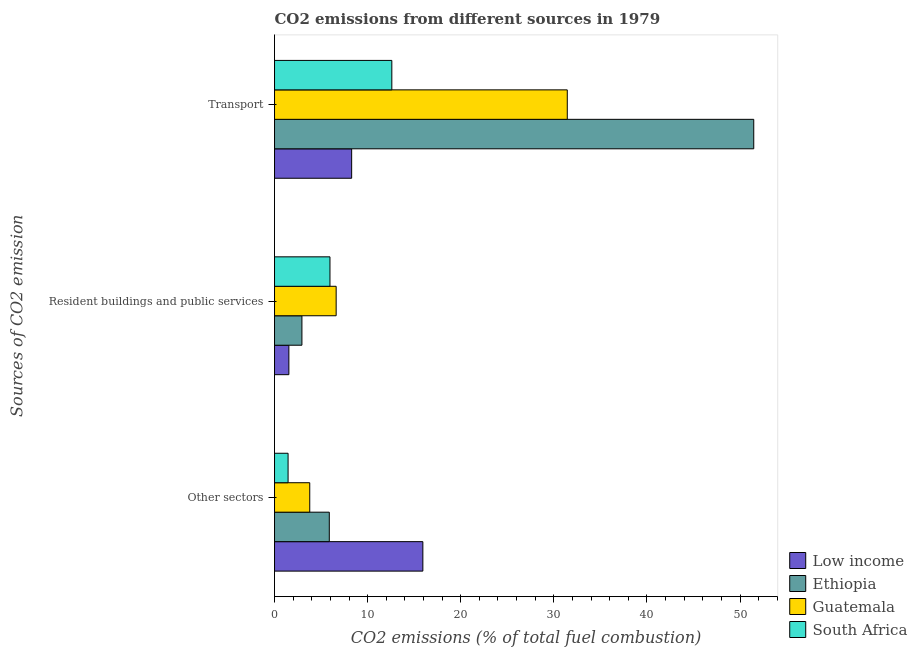How many different coloured bars are there?
Keep it short and to the point. 4. Are the number of bars per tick equal to the number of legend labels?
Ensure brevity in your answer.  Yes. How many bars are there on the 2nd tick from the bottom?
Your response must be concise. 4. What is the label of the 1st group of bars from the top?
Your response must be concise. Transport. What is the percentage of co2 emissions from other sectors in South Africa?
Give a very brief answer. 1.46. Across all countries, what is the maximum percentage of co2 emissions from resident buildings and public services?
Make the answer very short. 6.62. Across all countries, what is the minimum percentage of co2 emissions from resident buildings and public services?
Provide a short and direct response. 1.54. In which country was the percentage of co2 emissions from other sectors maximum?
Your response must be concise. Low income. In which country was the percentage of co2 emissions from resident buildings and public services minimum?
Provide a short and direct response. Low income. What is the total percentage of co2 emissions from other sectors in the graph?
Offer a very short reply. 27.05. What is the difference between the percentage of co2 emissions from transport in South Africa and that in Low income?
Provide a short and direct response. 4.31. What is the difference between the percentage of co2 emissions from resident buildings and public services in Low income and the percentage of co2 emissions from transport in South Africa?
Your answer should be compact. -11.06. What is the average percentage of co2 emissions from transport per country?
Make the answer very short. 25.95. What is the difference between the percentage of co2 emissions from transport and percentage of co2 emissions from resident buildings and public services in Ethiopia?
Offer a terse response. 48.53. What is the ratio of the percentage of co2 emissions from other sectors in Guatemala to that in Ethiopia?
Provide a short and direct response. 0.64. Is the percentage of co2 emissions from transport in Guatemala less than that in South Africa?
Offer a very short reply. No. What is the difference between the highest and the second highest percentage of co2 emissions from resident buildings and public services?
Keep it short and to the point. 0.67. What is the difference between the highest and the lowest percentage of co2 emissions from resident buildings and public services?
Your answer should be compact. 5.08. In how many countries, is the percentage of co2 emissions from other sectors greater than the average percentage of co2 emissions from other sectors taken over all countries?
Ensure brevity in your answer.  1. Is the sum of the percentage of co2 emissions from resident buildings and public services in Guatemala and Low income greater than the maximum percentage of co2 emissions from other sectors across all countries?
Give a very brief answer. No. What does the 3rd bar from the top in Other sectors represents?
Ensure brevity in your answer.  Ethiopia. What does the 2nd bar from the bottom in Transport represents?
Provide a short and direct response. Ethiopia. How many bars are there?
Your answer should be compact. 12. Are all the bars in the graph horizontal?
Your response must be concise. Yes. How many countries are there in the graph?
Provide a succinct answer. 4. What is the difference between two consecutive major ticks on the X-axis?
Ensure brevity in your answer.  10. Does the graph contain any zero values?
Keep it short and to the point. No. Where does the legend appear in the graph?
Your response must be concise. Bottom right. How many legend labels are there?
Provide a succinct answer. 4. How are the legend labels stacked?
Provide a succinct answer. Vertical. What is the title of the graph?
Provide a succinct answer. CO2 emissions from different sources in 1979. What is the label or title of the X-axis?
Your answer should be very brief. CO2 emissions (% of total fuel combustion). What is the label or title of the Y-axis?
Ensure brevity in your answer.  Sources of CO2 emission. What is the CO2 emissions (% of total fuel combustion) of Low income in Other sectors?
Provide a short and direct response. 15.93. What is the CO2 emissions (% of total fuel combustion) of Ethiopia in Other sectors?
Offer a terse response. 5.88. What is the CO2 emissions (% of total fuel combustion) in Guatemala in Other sectors?
Make the answer very short. 3.78. What is the CO2 emissions (% of total fuel combustion) of South Africa in Other sectors?
Your answer should be compact. 1.46. What is the CO2 emissions (% of total fuel combustion) of Low income in Resident buildings and public services?
Make the answer very short. 1.54. What is the CO2 emissions (% of total fuel combustion) of Ethiopia in Resident buildings and public services?
Keep it short and to the point. 2.94. What is the CO2 emissions (% of total fuel combustion) in Guatemala in Resident buildings and public services?
Your answer should be very brief. 6.62. What is the CO2 emissions (% of total fuel combustion) of South Africa in Resident buildings and public services?
Your response must be concise. 5.95. What is the CO2 emissions (% of total fuel combustion) in Low income in Transport?
Offer a terse response. 8.28. What is the CO2 emissions (% of total fuel combustion) in Ethiopia in Transport?
Ensure brevity in your answer.  51.47. What is the CO2 emissions (% of total fuel combustion) of Guatemala in Transport?
Provide a succinct answer. 31.44. What is the CO2 emissions (% of total fuel combustion) of South Africa in Transport?
Give a very brief answer. 12.6. Across all Sources of CO2 emission, what is the maximum CO2 emissions (% of total fuel combustion) of Low income?
Give a very brief answer. 15.93. Across all Sources of CO2 emission, what is the maximum CO2 emissions (% of total fuel combustion) of Ethiopia?
Your response must be concise. 51.47. Across all Sources of CO2 emission, what is the maximum CO2 emissions (% of total fuel combustion) in Guatemala?
Provide a succinct answer. 31.44. Across all Sources of CO2 emission, what is the maximum CO2 emissions (% of total fuel combustion) in South Africa?
Keep it short and to the point. 12.6. Across all Sources of CO2 emission, what is the minimum CO2 emissions (% of total fuel combustion) of Low income?
Keep it short and to the point. 1.54. Across all Sources of CO2 emission, what is the minimum CO2 emissions (% of total fuel combustion) of Ethiopia?
Your answer should be compact. 2.94. Across all Sources of CO2 emission, what is the minimum CO2 emissions (% of total fuel combustion) in Guatemala?
Your answer should be compact. 3.78. Across all Sources of CO2 emission, what is the minimum CO2 emissions (% of total fuel combustion) of South Africa?
Provide a short and direct response. 1.46. What is the total CO2 emissions (% of total fuel combustion) of Low income in the graph?
Give a very brief answer. 25.76. What is the total CO2 emissions (% of total fuel combustion) in Ethiopia in the graph?
Ensure brevity in your answer.  60.29. What is the total CO2 emissions (% of total fuel combustion) of Guatemala in the graph?
Your answer should be compact. 41.84. What is the total CO2 emissions (% of total fuel combustion) of South Africa in the graph?
Your answer should be compact. 20.01. What is the difference between the CO2 emissions (% of total fuel combustion) in Low income in Other sectors and that in Resident buildings and public services?
Your answer should be very brief. 14.39. What is the difference between the CO2 emissions (% of total fuel combustion) of Ethiopia in Other sectors and that in Resident buildings and public services?
Your answer should be compact. 2.94. What is the difference between the CO2 emissions (% of total fuel combustion) in Guatemala in Other sectors and that in Resident buildings and public services?
Provide a short and direct response. -2.84. What is the difference between the CO2 emissions (% of total fuel combustion) in South Africa in Other sectors and that in Resident buildings and public services?
Offer a very short reply. -4.5. What is the difference between the CO2 emissions (% of total fuel combustion) in Low income in Other sectors and that in Transport?
Provide a succinct answer. 7.65. What is the difference between the CO2 emissions (% of total fuel combustion) of Ethiopia in Other sectors and that in Transport?
Your answer should be very brief. -45.59. What is the difference between the CO2 emissions (% of total fuel combustion) in Guatemala in Other sectors and that in Transport?
Keep it short and to the point. -27.66. What is the difference between the CO2 emissions (% of total fuel combustion) of South Africa in Other sectors and that in Transport?
Make the answer very short. -11.14. What is the difference between the CO2 emissions (% of total fuel combustion) in Low income in Resident buildings and public services and that in Transport?
Your answer should be compact. -6.74. What is the difference between the CO2 emissions (% of total fuel combustion) in Ethiopia in Resident buildings and public services and that in Transport?
Keep it short and to the point. -48.53. What is the difference between the CO2 emissions (% of total fuel combustion) in Guatemala in Resident buildings and public services and that in Transport?
Your response must be concise. -24.82. What is the difference between the CO2 emissions (% of total fuel combustion) in South Africa in Resident buildings and public services and that in Transport?
Provide a succinct answer. -6.64. What is the difference between the CO2 emissions (% of total fuel combustion) of Low income in Other sectors and the CO2 emissions (% of total fuel combustion) of Ethiopia in Resident buildings and public services?
Your answer should be compact. 12.99. What is the difference between the CO2 emissions (% of total fuel combustion) in Low income in Other sectors and the CO2 emissions (% of total fuel combustion) in Guatemala in Resident buildings and public services?
Your answer should be compact. 9.31. What is the difference between the CO2 emissions (% of total fuel combustion) of Low income in Other sectors and the CO2 emissions (% of total fuel combustion) of South Africa in Resident buildings and public services?
Ensure brevity in your answer.  9.98. What is the difference between the CO2 emissions (% of total fuel combustion) of Ethiopia in Other sectors and the CO2 emissions (% of total fuel combustion) of Guatemala in Resident buildings and public services?
Your answer should be compact. -0.74. What is the difference between the CO2 emissions (% of total fuel combustion) of Ethiopia in Other sectors and the CO2 emissions (% of total fuel combustion) of South Africa in Resident buildings and public services?
Provide a succinct answer. -0.07. What is the difference between the CO2 emissions (% of total fuel combustion) of Guatemala in Other sectors and the CO2 emissions (% of total fuel combustion) of South Africa in Resident buildings and public services?
Offer a terse response. -2.17. What is the difference between the CO2 emissions (% of total fuel combustion) in Low income in Other sectors and the CO2 emissions (% of total fuel combustion) in Ethiopia in Transport?
Offer a very short reply. -35.54. What is the difference between the CO2 emissions (% of total fuel combustion) of Low income in Other sectors and the CO2 emissions (% of total fuel combustion) of Guatemala in Transport?
Give a very brief answer. -15.51. What is the difference between the CO2 emissions (% of total fuel combustion) of Low income in Other sectors and the CO2 emissions (% of total fuel combustion) of South Africa in Transport?
Provide a short and direct response. 3.33. What is the difference between the CO2 emissions (% of total fuel combustion) of Ethiopia in Other sectors and the CO2 emissions (% of total fuel combustion) of Guatemala in Transport?
Offer a very short reply. -25.56. What is the difference between the CO2 emissions (% of total fuel combustion) of Ethiopia in Other sectors and the CO2 emissions (% of total fuel combustion) of South Africa in Transport?
Offer a terse response. -6.72. What is the difference between the CO2 emissions (% of total fuel combustion) in Guatemala in Other sectors and the CO2 emissions (% of total fuel combustion) in South Africa in Transport?
Give a very brief answer. -8.82. What is the difference between the CO2 emissions (% of total fuel combustion) of Low income in Resident buildings and public services and the CO2 emissions (% of total fuel combustion) of Ethiopia in Transport?
Your response must be concise. -49.93. What is the difference between the CO2 emissions (% of total fuel combustion) of Low income in Resident buildings and public services and the CO2 emissions (% of total fuel combustion) of Guatemala in Transport?
Your answer should be compact. -29.9. What is the difference between the CO2 emissions (% of total fuel combustion) of Low income in Resident buildings and public services and the CO2 emissions (% of total fuel combustion) of South Africa in Transport?
Offer a terse response. -11.06. What is the difference between the CO2 emissions (% of total fuel combustion) of Ethiopia in Resident buildings and public services and the CO2 emissions (% of total fuel combustion) of Guatemala in Transport?
Offer a terse response. -28.5. What is the difference between the CO2 emissions (% of total fuel combustion) of Ethiopia in Resident buildings and public services and the CO2 emissions (% of total fuel combustion) of South Africa in Transport?
Give a very brief answer. -9.66. What is the difference between the CO2 emissions (% of total fuel combustion) in Guatemala in Resident buildings and public services and the CO2 emissions (% of total fuel combustion) in South Africa in Transport?
Keep it short and to the point. -5.98. What is the average CO2 emissions (% of total fuel combustion) of Low income per Sources of CO2 emission?
Your answer should be very brief. 8.59. What is the average CO2 emissions (% of total fuel combustion) in Ethiopia per Sources of CO2 emission?
Your answer should be compact. 20.1. What is the average CO2 emissions (% of total fuel combustion) of Guatemala per Sources of CO2 emission?
Your response must be concise. 13.95. What is the average CO2 emissions (% of total fuel combustion) of South Africa per Sources of CO2 emission?
Make the answer very short. 6.67. What is the difference between the CO2 emissions (% of total fuel combustion) in Low income and CO2 emissions (% of total fuel combustion) in Ethiopia in Other sectors?
Give a very brief answer. 10.05. What is the difference between the CO2 emissions (% of total fuel combustion) of Low income and CO2 emissions (% of total fuel combustion) of Guatemala in Other sectors?
Your answer should be compact. 12.15. What is the difference between the CO2 emissions (% of total fuel combustion) in Low income and CO2 emissions (% of total fuel combustion) in South Africa in Other sectors?
Your response must be concise. 14.48. What is the difference between the CO2 emissions (% of total fuel combustion) in Ethiopia and CO2 emissions (% of total fuel combustion) in Guatemala in Other sectors?
Provide a succinct answer. 2.1. What is the difference between the CO2 emissions (% of total fuel combustion) of Ethiopia and CO2 emissions (% of total fuel combustion) of South Africa in Other sectors?
Your answer should be compact. 4.43. What is the difference between the CO2 emissions (% of total fuel combustion) in Guatemala and CO2 emissions (% of total fuel combustion) in South Africa in Other sectors?
Keep it short and to the point. 2.33. What is the difference between the CO2 emissions (% of total fuel combustion) of Low income and CO2 emissions (% of total fuel combustion) of Ethiopia in Resident buildings and public services?
Provide a short and direct response. -1.4. What is the difference between the CO2 emissions (% of total fuel combustion) of Low income and CO2 emissions (% of total fuel combustion) of Guatemala in Resident buildings and public services?
Keep it short and to the point. -5.08. What is the difference between the CO2 emissions (% of total fuel combustion) in Low income and CO2 emissions (% of total fuel combustion) in South Africa in Resident buildings and public services?
Make the answer very short. -4.41. What is the difference between the CO2 emissions (% of total fuel combustion) of Ethiopia and CO2 emissions (% of total fuel combustion) of Guatemala in Resident buildings and public services?
Give a very brief answer. -3.68. What is the difference between the CO2 emissions (% of total fuel combustion) in Ethiopia and CO2 emissions (% of total fuel combustion) in South Africa in Resident buildings and public services?
Your answer should be compact. -3.01. What is the difference between the CO2 emissions (% of total fuel combustion) in Guatemala and CO2 emissions (% of total fuel combustion) in South Africa in Resident buildings and public services?
Offer a very short reply. 0.67. What is the difference between the CO2 emissions (% of total fuel combustion) in Low income and CO2 emissions (% of total fuel combustion) in Ethiopia in Transport?
Your answer should be compact. -43.19. What is the difference between the CO2 emissions (% of total fuel combustion) of Low income and CO2 emissions (% of total fuel combustion) of Guatemala in Transport?
Offer a very short reply. -23.16. What is the difference between the CO2 emissions (% of total fuel combustion) in Low income and CO2 emissions (% of total fuel combustion) in South Africa in Transport?
Give a very brief answer. -4.31. What is the difference between the CO2 emissions (% of total fuel combustion) of Ethiopia and CO2 emissions (% of total fuel combustion) of Guatemala in Transport?
Your response must be concise. 20.03. What is the difference between the CO2 emissions (% of total fuel combustion) of Ethiopia and CO2 emissions (% of total fuel combustion) of South Africa in Transport?
Make the answer very short. 38.87. What is the difference between the CO2 emissions (% of total fuel combustion) of Guatemala and CO2 emissions (% of total fuel combustion) of South Africa in Transport?
Provide a succinct answer. 18.84. What is the ratio of the CO2 emissions (% of total fuel combustion) in Low income in Other sectors to that in Resident buildings and public services?
Give a very brief answer. 10.34. What is the ratio of the CO2 emissions (% of total fuel combustion) in Ethiopia in Other sectors to that in Resident buildings and public services?
Offer a terse response. 2. What is the ratio of the CO2 emissions (% of total fuel combustion) in Guatemala in Other sectors to that in Resident buildings and public services?
Offer a very short reply. 0.57. What is the ratio of the CO2 emissions (% of total fuel combustion) of South Africa in Other sectors to that in Resident buildings and public services?
Your answer should be very brief. 0.24. What is the ratio of the CO2 emissions (% of total fuel combustion) in Low income in Other sectors to that in Transport?
Make the answer very short. 1.92. What is the ratio of the CO2 emissions (% of total fuel combustion) in Ethiopia in Other sectors to that in Transport?
Provide a short and direct response. 0.11. What is the ratio of the CO2 emissions (% of total fuel combustion) in Guatemala in Other sectors to that in Transport?
Provide a short and direct response. 0.12. What is the ratio of the CO2 emissions (% of total fuel combustion) in South Africa in Other sectors to that in Transport?
Ensure brevity in your answer.  0.12. What is the ratio of the CO2 emissions (% of total fuel combustion) in Low income in Resident buildings and public services to that in Transport?
Your answer should be very brief. 0.19. What is the ratio of the CO2 emissions (% of total fuel combustion) in Ethiopia in Resident buildings and public services to that in Transport?
Offer a very short reply. 0.06. What is the ratio of the CO2 emissions (% of total fuel combustion) of Guatemala in Resident buildings and public services to that in Transport?
Offer a terse response. 0.21. What is the ratio of the CO2 emissions (% of total fuel combustion) of South Africa in Resident buildings and public services to that in Transport?
Ensure brevity in your answer.  0.47. What is the difference between the highest and the second highest CO2 emissions (% of total fuel combustion) of Low income?
Give a very brief answer. 7.65. What is the difference between the highest and the second highest CO2 emissions (% of total fuel combustion) in Ethiopia?
Give a very brief answer. 45.59. What is the difference between the highest and the second highest CO2 emissions (% of total fuel combustion) of Guatemala?
Offer a terse response. 24.82. What is the difference between the highest and the second highest CO2 emissions (% of total fuel combustion) of South Africa?
Make the answer very short. 6.64. What is the difference between the highest and the lowest CO2 emissions (% of total fuel combustion) of Low income?
Provide a short and direct response. 14.39. What is the difference between the highest and the lowest CO2 emissions (% of total fuel combustion) in Ethiopia?
Provide a short and direct response. 48.53. What is the difference between the highest and the lowest CO2 emissions (% of total fuel combustion) in Guatemala?
Keep it short and to the point. 27.66. What is the difference between the highest and the lowest CO2 emissions (% of total fuel combustion) of South Africa?
Your response must be concise. 11.14. 